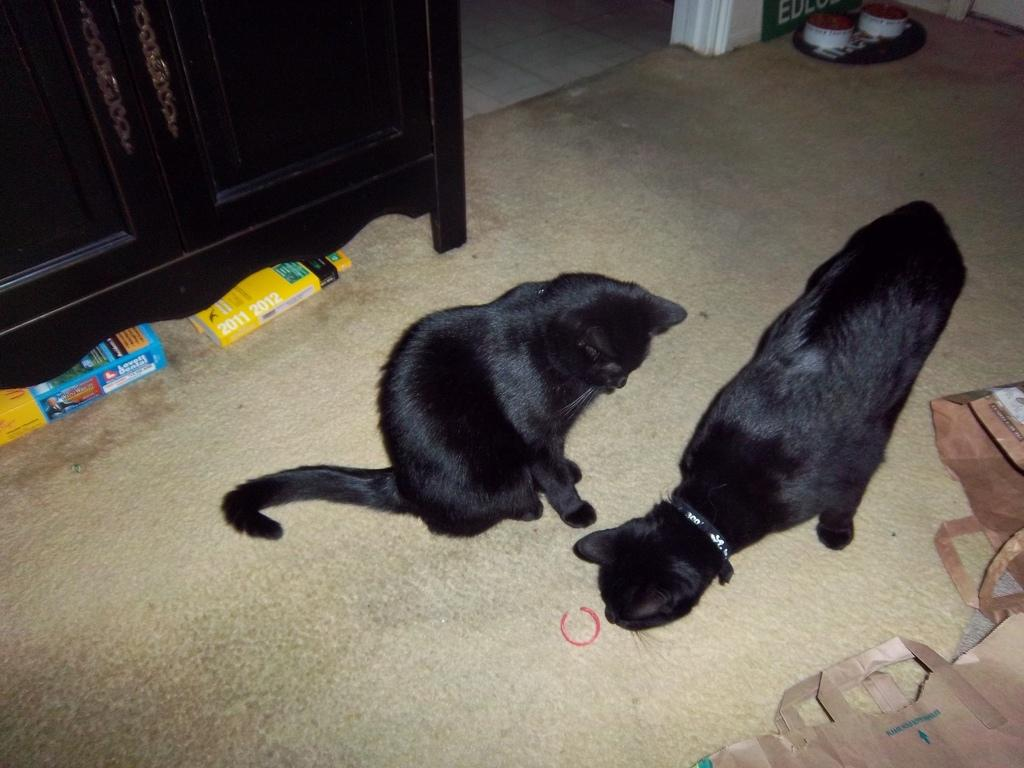What type of animals can be seen on the floor in the image? There are two black color cats on the floor. What items related to reading are present in the image? There are two books and paper covers in the image. Can you describe any other objects in the image? Yes, there are some objects in the image. What type of furniture is visible in the image? There is a wooden cupboard in the image. Can you describe the taste of the wooden cupboard in the image? The wooden cupboard in the image does not have a taste, as it is an inanimate object made of wood. 